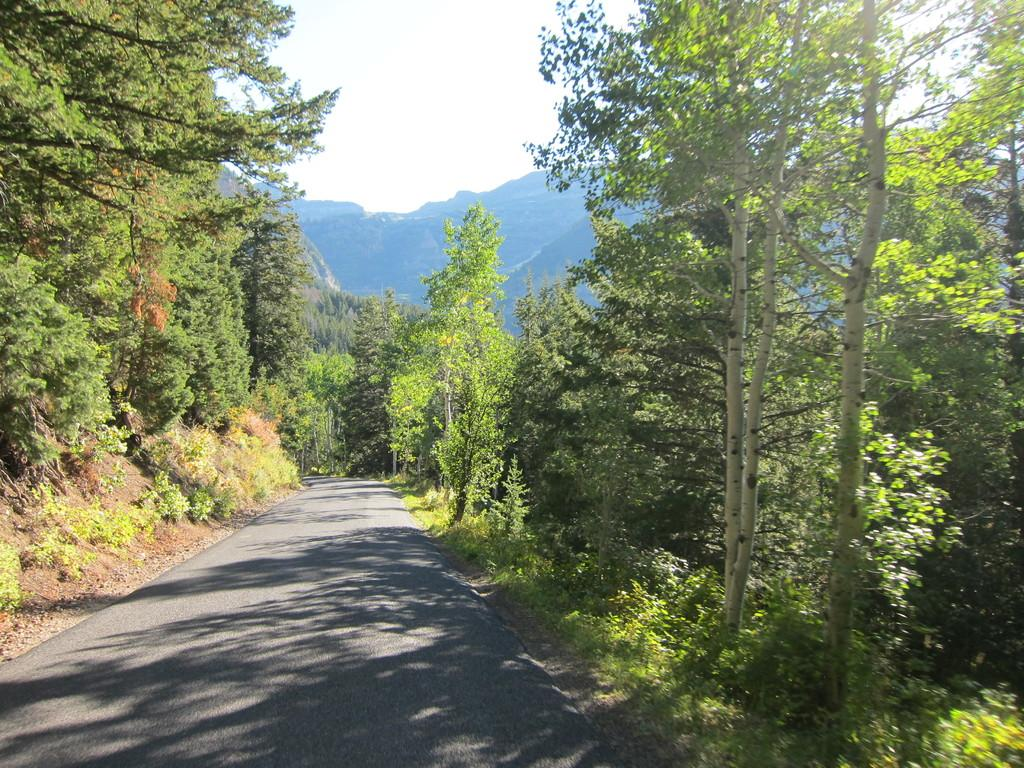What type of natural formation can be seen in the image? There are mountains in the image. What other natural elements are present in the image? There are trees and plants in the image. What is visible at the top of the image? The sky is visible at the top of the image. What type of man-made structure can be seen at the bottom of the image? There is a road at the bottom of the image. What type of wax can be seen dripping from the trees in the image? There is no wax present in the image; the trees are not depicted as dripping wax. 